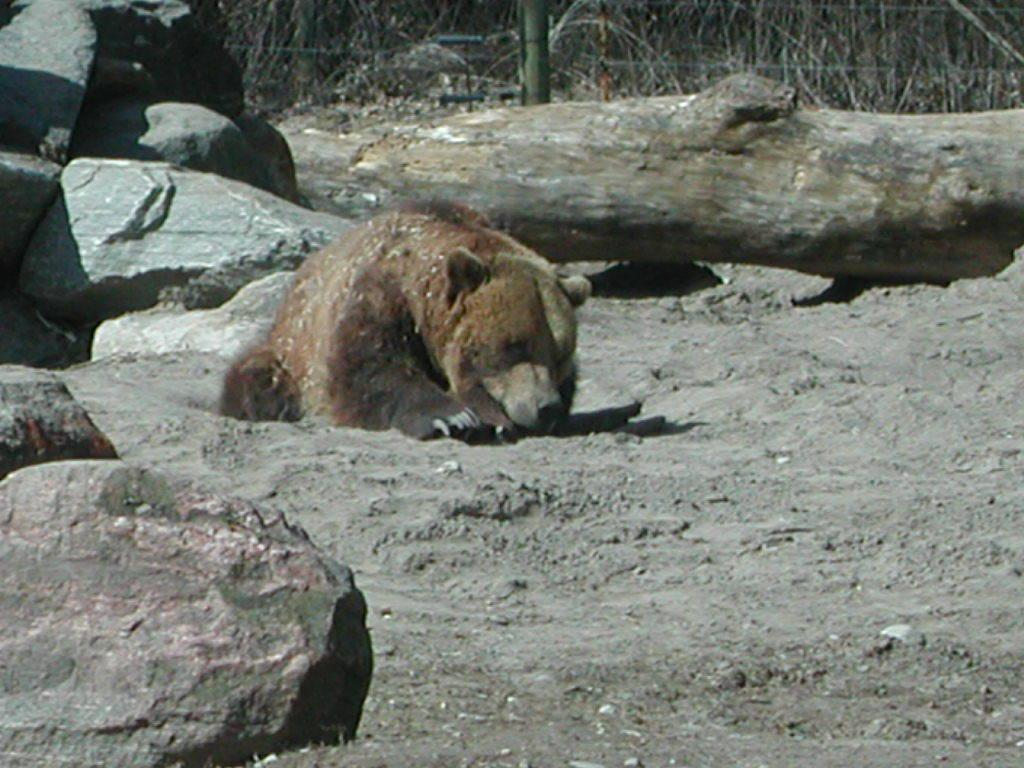What animal is present in the image? There is a bear in the image. What color is the bear? The bear is light brown in color. What type of object can be seen in the image besides the bear? There is a wooden log, a stand, a pole, and rocks in the image. What type of pipe can be seen in the image? There is no pipe present in the image. What role does the father play in the image? There is no reference to a father or any human figures in the image, so it's not possible to determine their role. 